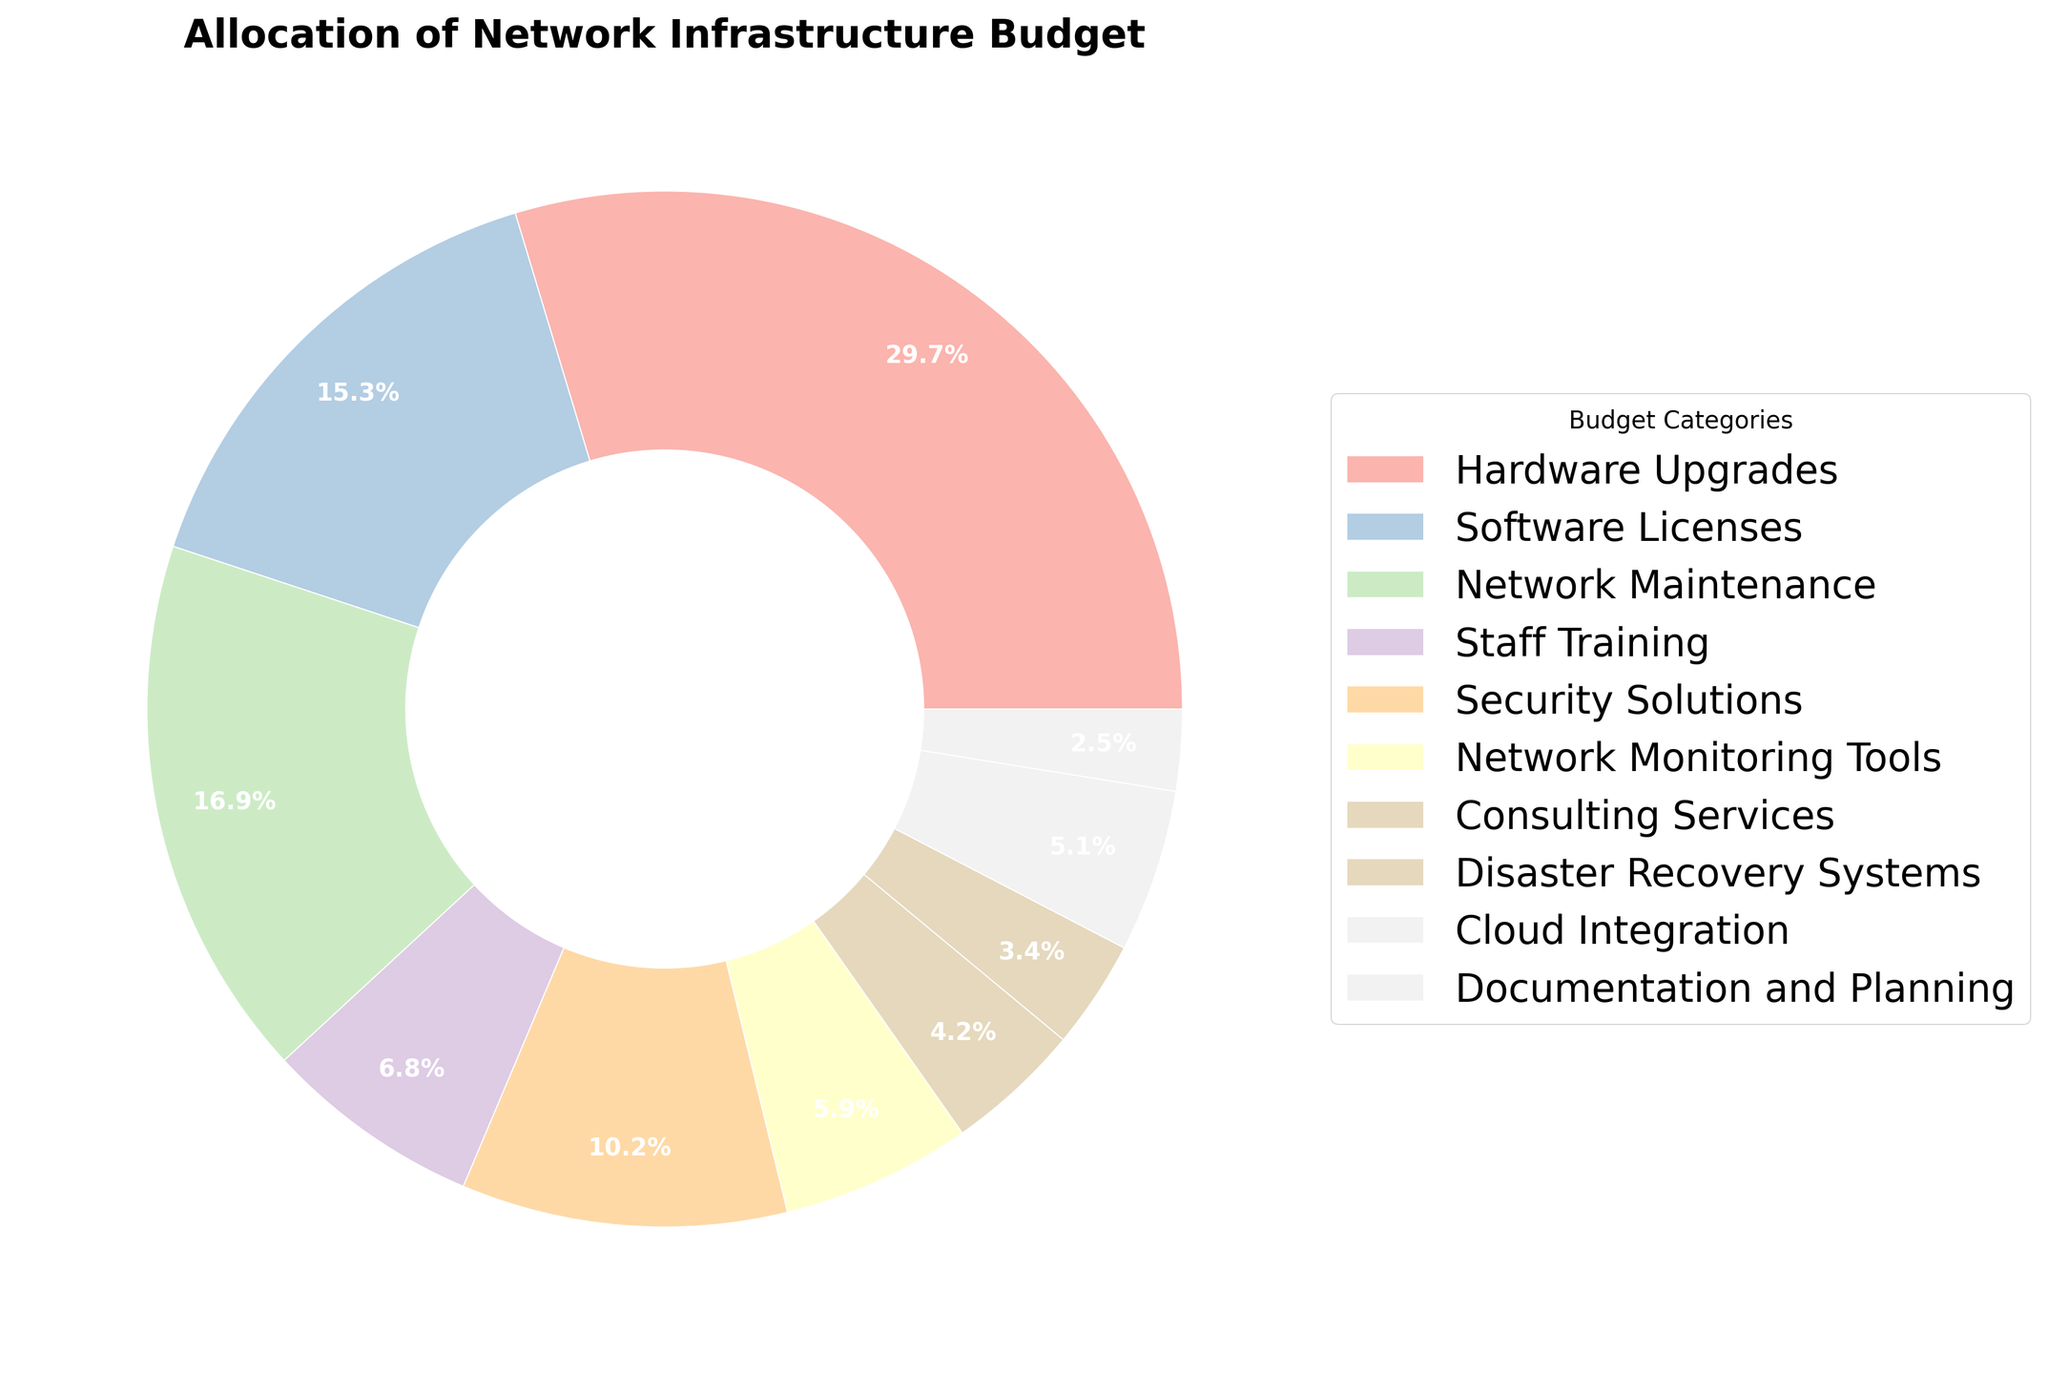What is the largest allocation category in the network infrastructure budget? By examining the pie chart, identify which segment is the largest. This segment represents the largest allocation category.
Answer: Hardware Upgrades Which category has a smaller budget allocation: Software Licenses or Security Solutions? Compare the size of the pie segments for Software Licenses and Security Solutions. The smaller segment indicates the smaller budget allocation.
Answer: Security Solutions What is the total percentage allocated to Network Maintenance and Staff Training combined? Locate the percentages for Network Maintenance and Staff Training in the pie chart. Add these percentages together: 20% (Network Maintenance) + 8% (Staff Training) = 28%.
Answer: 28% Which has a smaller allocation: Consulting Services or Documentation and Planning? Compare the pie segments for Consulting Services and Documentation and Planning. The smaller segment indicates the smaller allocation.
Answer: Documentation and Planning What is the percentage difference between Hardware Upgrades and Software Licenses? Find the percentages for Hardware Upgrades and Software Licenses. Subtract the smaller percentage from the larger one: 35% (Hardware Upgrades) - 18% (Software Licenses) = 17%.
Answer: 17% What is the combined budget allocation for categories with less than 10% each? Identify the categories with percentages less than 10%: Staff Training (8%), Network Monitoring Tools (7%), Consulting Services (5%), Disaster Recovery Systems (4%), Cloud Integration (6%), Documentation and Planning (3%). Add these percentages together: 8% + 7% + 5% + 4% + 6% + 3% = 33%.
Answer: 33% Which is allocated more: Cloud Integration or Disaster Recovery Systems? Compare the pie segments for Cloud Integration and Disaster Recovery Systems. The larger segment indicates the higher allocation.
Answer: Cloud Integration What is the total percentage of categories allocated between 5% and 15%? Identify the categories within the range of 5% to 15%: Security Solutions (12%), Network Monitoring Tools (7%), Consulting Services (5%). Add these percentages together: 12% + 7% + 5% = 24%.
Answer: 24% What is the central color used for the segment representing Network Maintenance? Identify the segment labeled Network Maintenance. Observe the color used for this segment.
Answer: Green (or the closest approximate if the exact color name is needed) Are there more categories allocated above or below 10%? Count the categories with percentages above 10% (Hardware Upgrades, Software Licenses, Network Maintenance, Security Solutions) and those below 10% (Staff Training, Network Monitoring Tools, Consulting Services, Disaster Recovery Systems, Cloud Integration, Documentation and Planning). Compare the counts.
Answer: Below 10% 